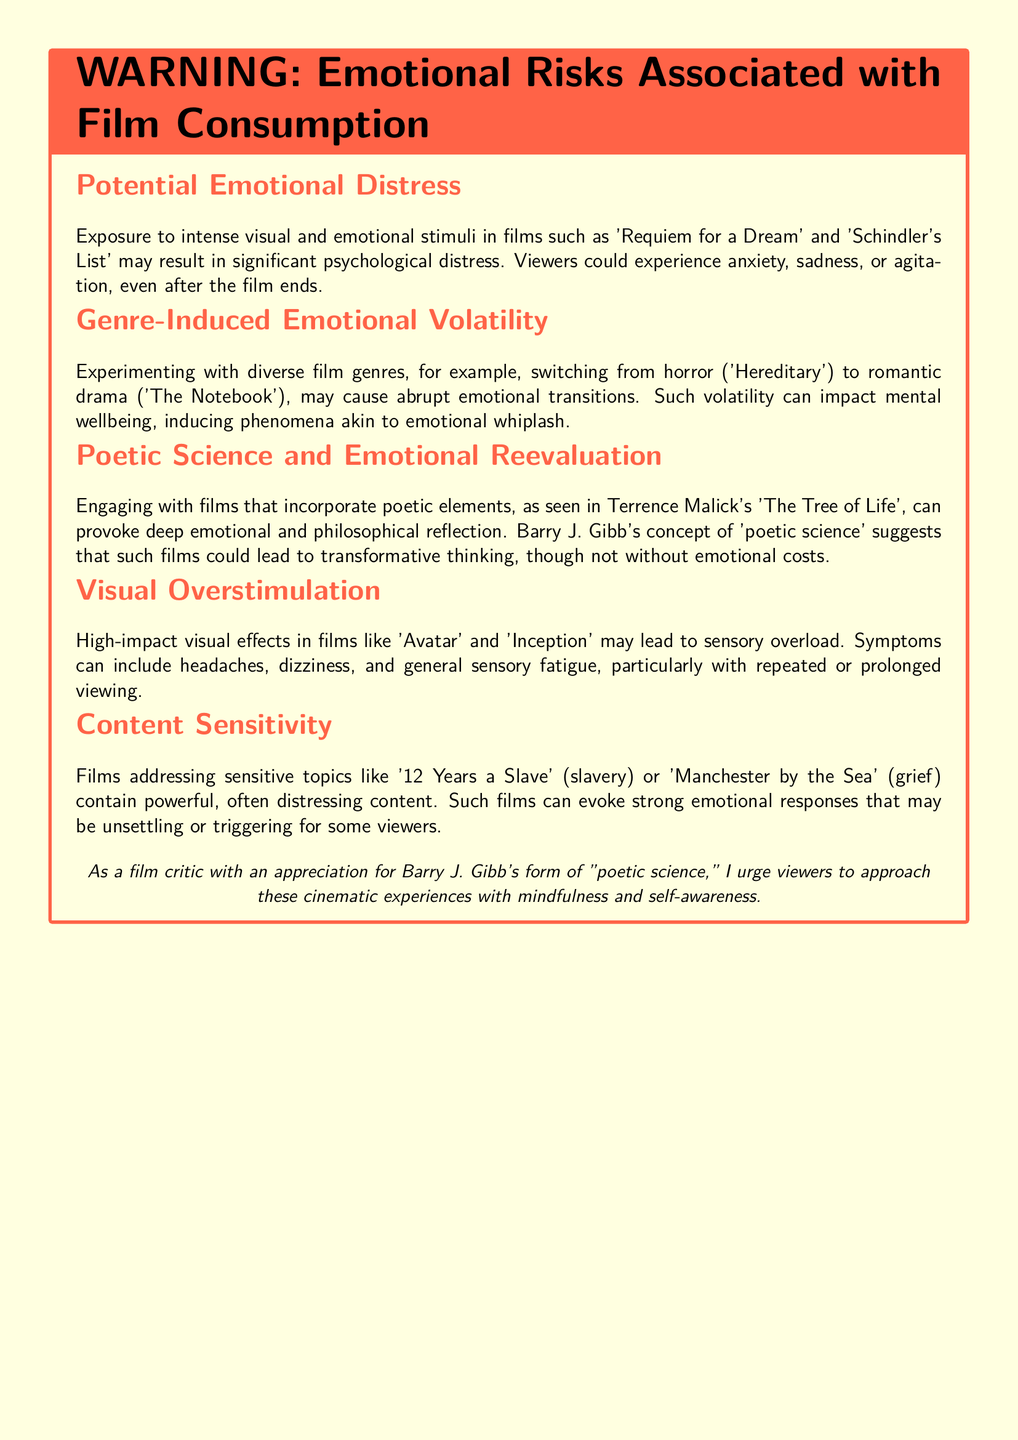What is the title of the warning label? The title of the warning label is highlighted prominently at the top of the document, which is "WARNING: Emotional Risks Associated with Film Consumption."
Answer: WARNING: Emotional Risks Associated with Film Consumption Which films are mentioned as examples of emotional distress? The document lists specific films that exemplify emotional distress, such as 'Requiem for a Dream' and 'Schindler's List.'
Answer: 'Requiem for a Dream' and 'Schindler's List' What type of films can cause emotional whiplash? The document indicates that switching between different genres can lead to emotional instability, specifically from horror to romantic drama.
Answer: Horror to romantic drama What concept does Barry J. Gibb's 'poetic science' relate to? The document explains that Barry J. Gibb’s concept relates to films that invoke deeper emotional and philosophical reflection.
Answer: Deeper emotional and philosophical reflection What symptoms may result from high-impact visual effects? The document outlines the potential symptoms stemming from visual overstimulation, which includes headaches and dizziness.
Answer: Headaches and dizziness Which film is an example of content sensitivity related to grief? The document specifically mentions 'Manchester by the Sea' as an example of a film that delves into grief-related themes.
Answer: 'Manchester by the Sea' How should viewers approach cinematic experiences according to the document? The document advises viewers to practice mindfulness and self-awareness when engaging with films.
Answer: Mindfulness and self-awareness What visual effects are discussed in relation to sensory overload? The document refers to 'Avatar' and 'Inception' as films with high-impact visual effects that can lead to sensory issues.
Answer: 'Avatar' and 'Inception' 